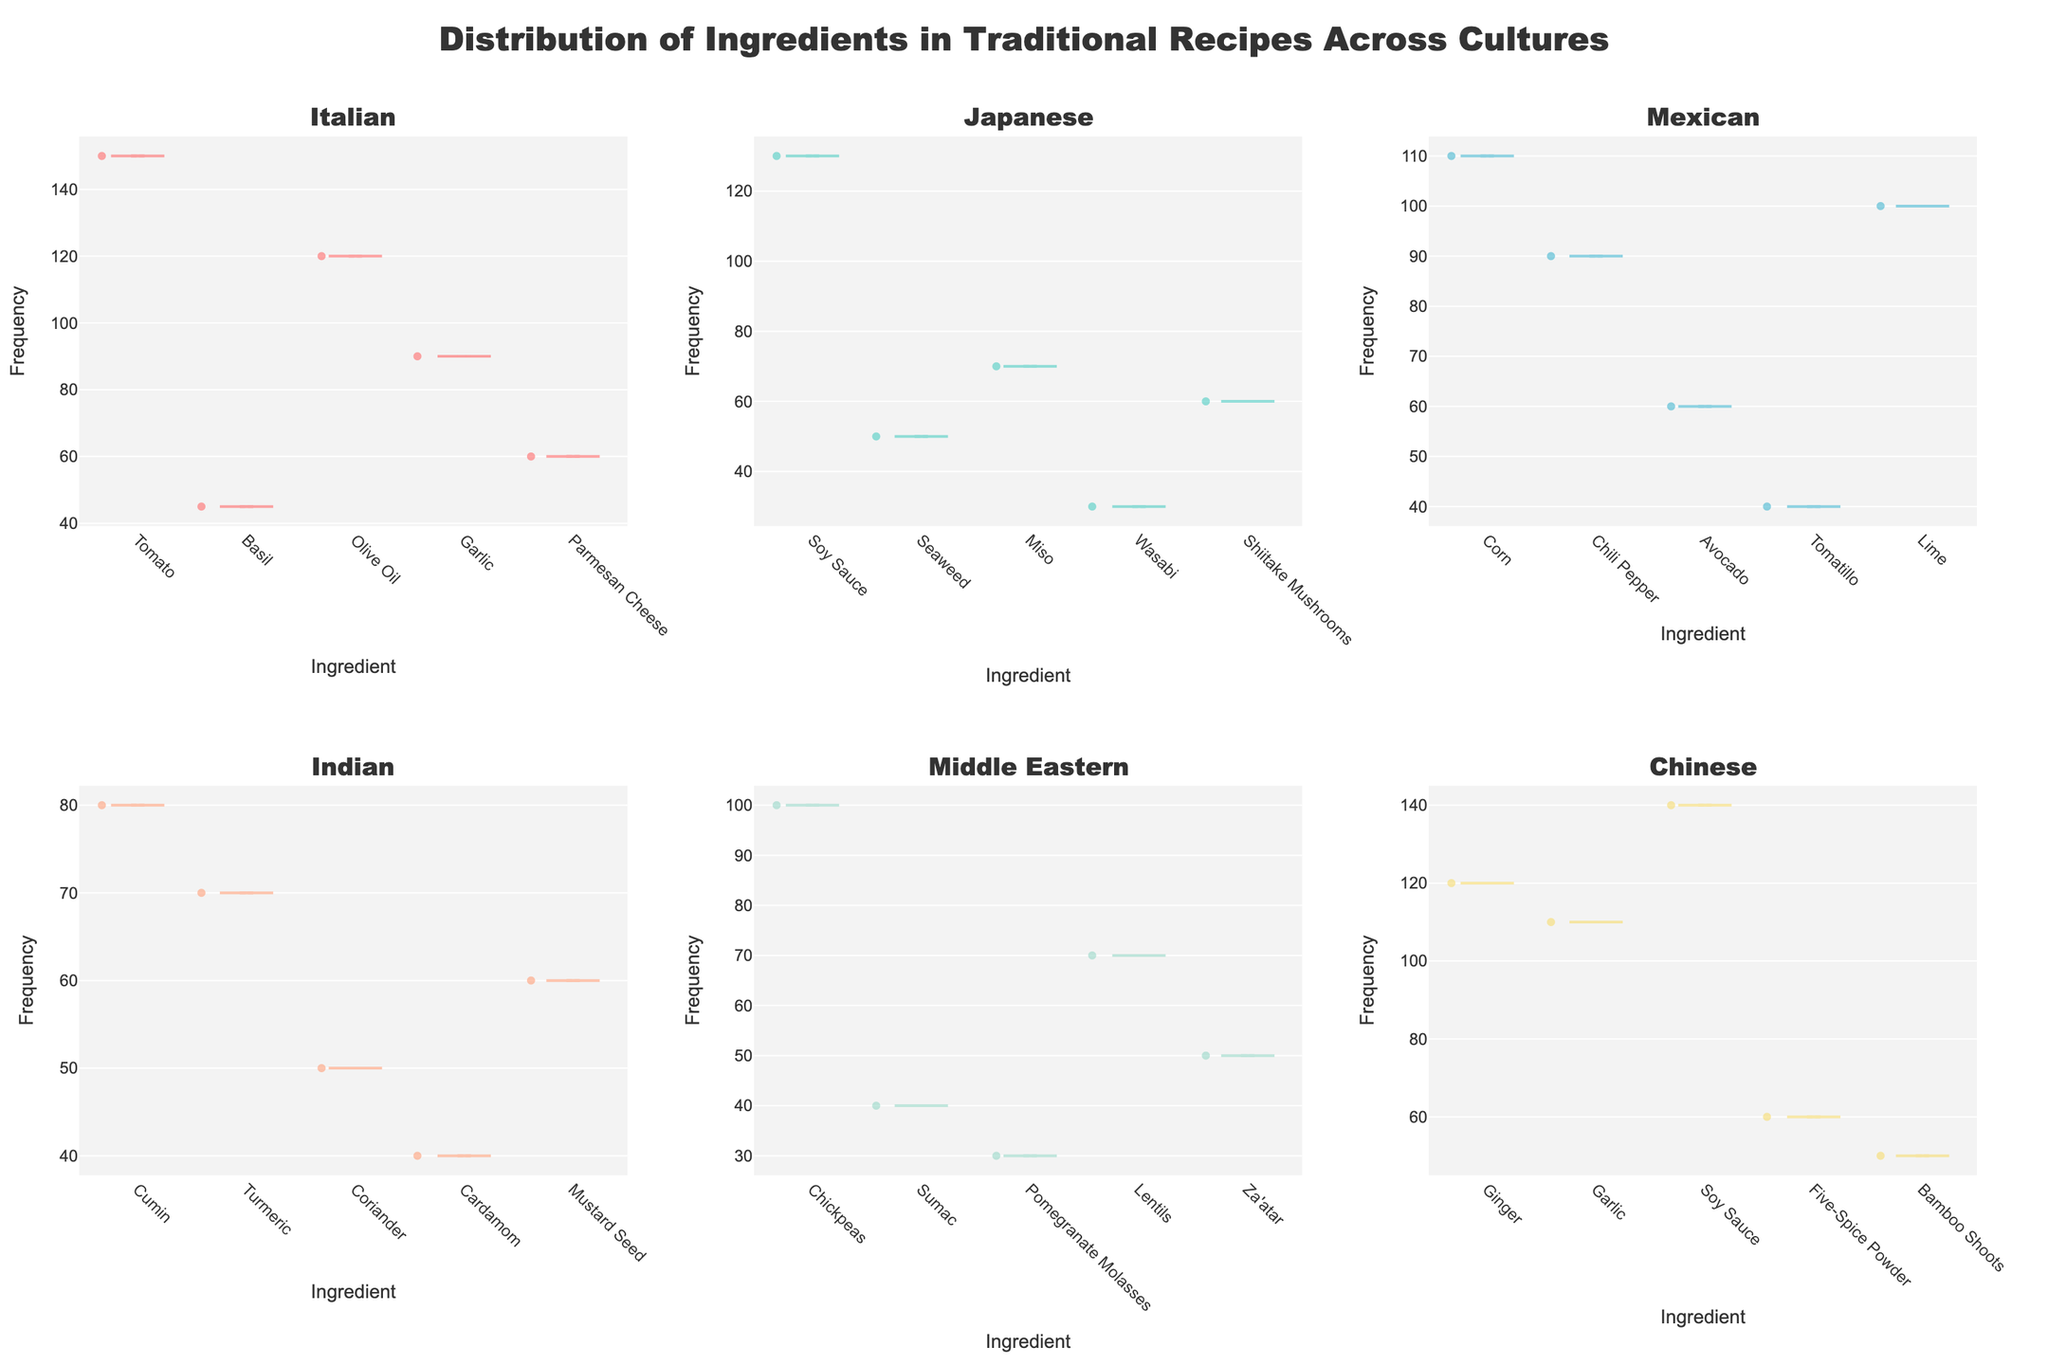What is the title of the figure? The title is often displayed prominently at the top of the figure. It provides an overview of what the plot represents.
Answer: Distribution of Ingredients in Traditional Recipes Across Cultures How many subplots are there in the figure? The figure has subplots arranged in a grid format. By counting these subplots, we can determine the total number.
Answer: 6 Which ingredient is used most frequently in Italian recipes? Look at the subplot titled "Italian" and identify the ingredient with the highest frequency value on the y-axis.
Answer: Tomato Which culture uses Ginger as an ingredient and how frequently? View each subplot to see where Ginger appears and check its frequency on the y-axis in the "Chinese" subplot.
Answer: Chinese, 120 Are there any ingredients that appear in more than one culture? Identify ingredients that are listed in multiple subplots by comparing the x-axes of all subplots.
Answer: Yes, Garlic and Soy Sauce Which culture uses Basil and how frequently? Locate the subplot where Basil is listed as an ingredient and note the frequency from the y-axis in the "Italian" subplot.
Answer: Italian, 45 What is the least used ingredient in Mexican recipes? In the "Mexican" subplot, identify the ingredient with the lowest frequency on the y-axis.
Answer: Tomatillo Compare the frequency of Soy Sauce usage between Japanese and Chinese cultures. Locate Soy Sauce in both the "Japanese" and "Chinese" subplots and compare their frequency values.
Answer: Japanese: 130, Chinese: 140 What is the most frequently used ingredient in the Middle Eastern subplot? Check the "Middle Eastern" subplot and identify which ingredient has the highest frequency on the y-axis.
Answer: Chickpeas Calculate the average frequency of the ingredients in the Indian subplot. Add up all the frequency values for the "Indian" subplot and divide by the number of ingredients: (80 + 70 + 50 + 40 + 60) / 5 = 60
Answer: 60 